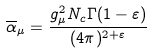<formula> <loc_0><loc_0><loc_500><loc_500>\overline { \alpha } _ { \mu } = \frac { g _ { \mu } ^ { 2 } N _ { c } \Gamma ( 1 - \varepsilon ) } { ( 4 \pi ) ^ { 2 + \varepsilon } }</formula> 